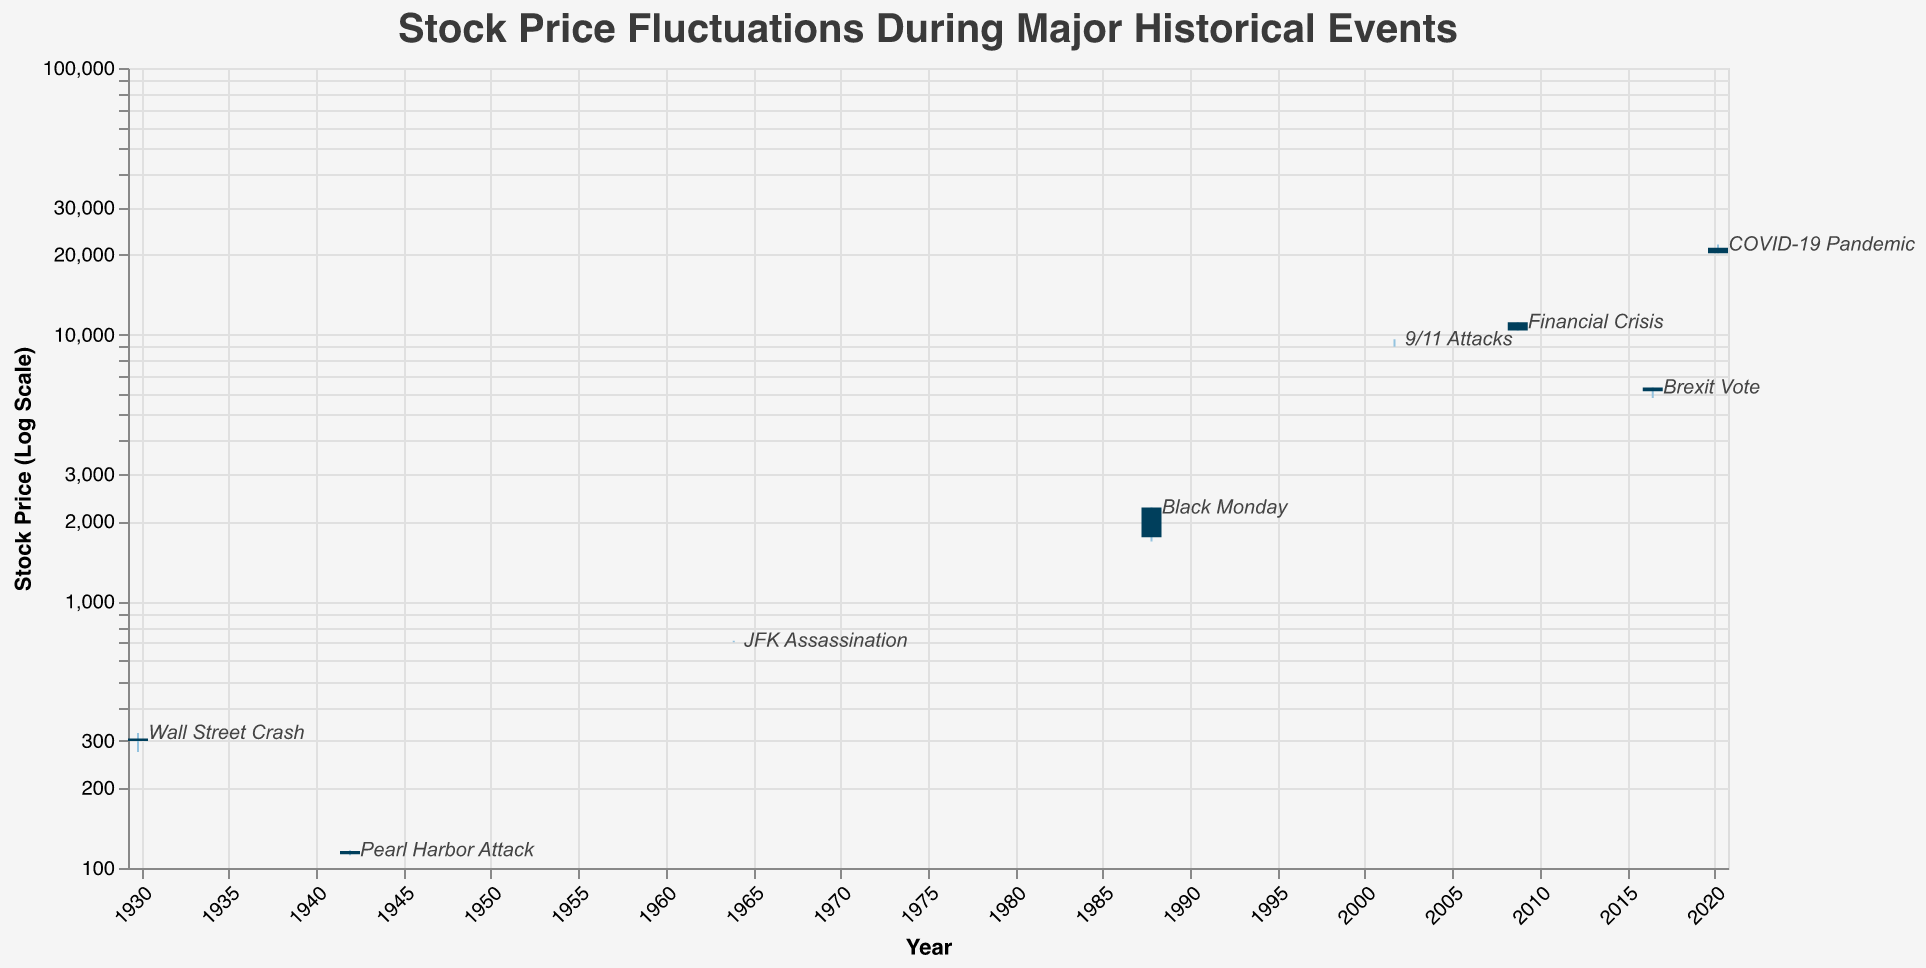What is the title of the chart? The title is located at the top of the chart, indicating the subject being visualized. In this chart, it reads "Stock Price Fluctuations During Major Historical Events."
Answer: Stock Price Fluctuations During Major Historical Events How many historical events are represented in the chart? By counting each distinct event label on the chart, we can determine the number of historical events shown. There are 8 events listed.
Answer: 8 What event has the largest difference between its high and low prices? To determine this, subtract the low price from the high price for each event. The COVID-19 Pandemic (March 2020) has the largest range: 21768.43 - 20188.52 = 1579.91.
Answer: COVID-19 Pandemic Which event had the highest closing price? By examining the "Close" values for each event, JFK Assassination (1963) had the highest closing price at 711.49.
Answer: JFK Assassination What trend is observed in stock prices during the events related to World War events (Pearl Harbor Attack vs. Financial Crisis)? Compare the "Low" and "Close" values for the Pearl Harbor Attack and Financial Crisis. Pearl Harbor saw a price drop (Close lower than Low), while the Financial Crisis ended close to its low point, indicating a steep decline.
Answer: Both show declines Which event had no gap between its open and close prices? The bar representing close prices at the same level as open prices indicates no gap. JFK Assassination, with open and close both at 711.49, shows no gap.
Answer: JFK Assassination Between the Wall Street Crash and Black Monday, which had a greater initial stock price? Compare the "Open" prices for these two events. Black Monday (1987) opened at 2246.73, higher than the Wall Street Crash (1929) at 305.85.
Answer: Black Monday What was the stock price action on the day of the 9/11 Attacks? Look at the open, high, low, and close values for the 9/11 Attacks (2001). The open and close are both 9605.51, and the low is 9000.00, indicating a rebound by the end of the same day.
Answer: Rebounded Calculate the average opening stock price across all the events. Sum all the open prices (305.85 + 115.90 + 711.49 + 2246.73 + 9605.51 + 11143.13 + 6338.10 + 21201.53) and divide by the number of events (8): (51068.24 / 8) = 6383.53.
Answer: 6383.53 How did Brexit affect the stock price trends compared to the COVID-19 Pandemic? By comparing the "Open," "High," "Low," and "Close" values, Brexit saw a significant drop but not as sharp as COVID-19 Pandemic, which had lower closing values.
Answer: COVID-19 was more severe 